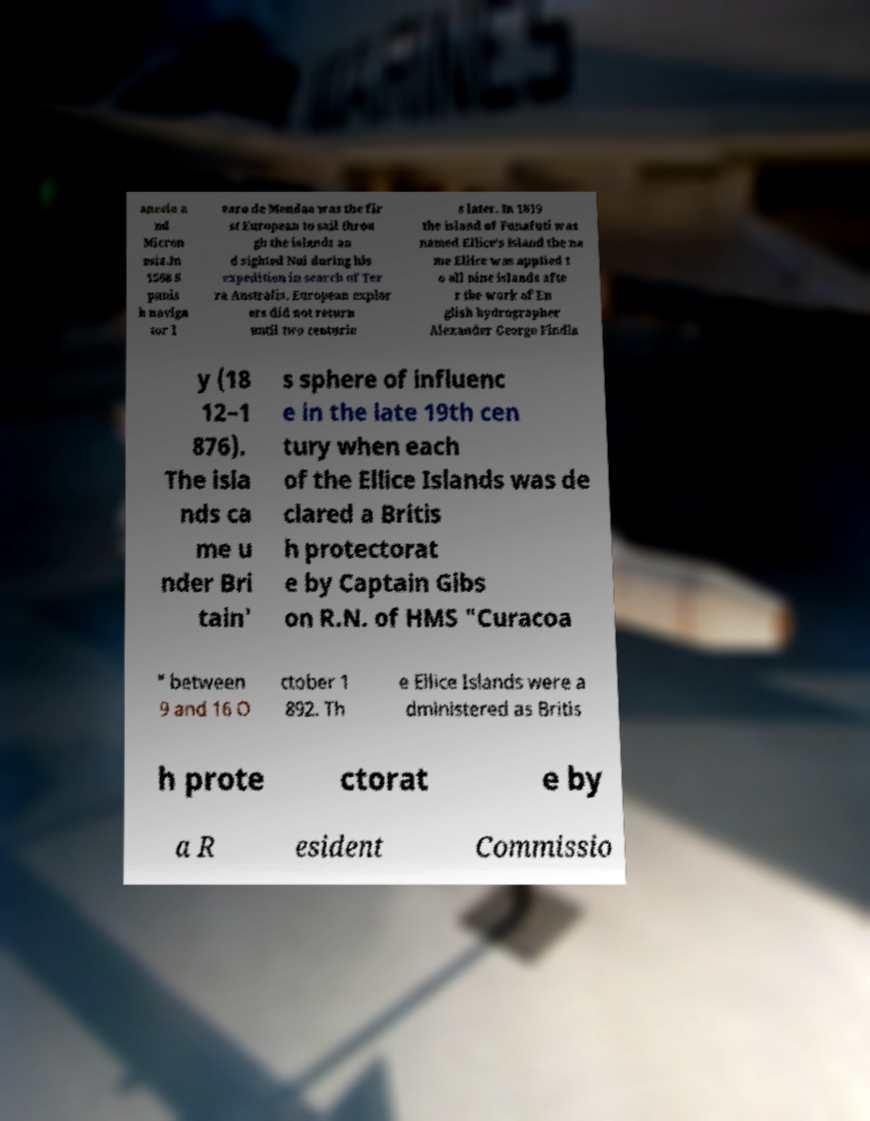Could you extract and type out the text from this image? anesia a nd Micron esia.In 1568 S panis h naviga tor l varo de Mendaa was the fir st European to sail throu gh the islands an d sighted Nui during his expedition in search of Ter ra Australis. European explor ers did not return until two centurie s later. In 1819 the island of Funafuti was named Ellice's Island the na me Ellice was applied t o all nine islands afte r the work of En glish hydrographer Alexander George Findla y (18 12–1 876). The isla nds ca me u nder Bri tain' s sphere of influenc e in the late 19th cen tury when each of the Ellice Islands was de clared a Britis h protectorat e by Captain Gibs on R.N. of HMS "Curacoa " between 9 and 16 O ctober 1 892. Th e Ellice Islands were a dministered as Britis h prote ctorat e by a R esident Commissio 